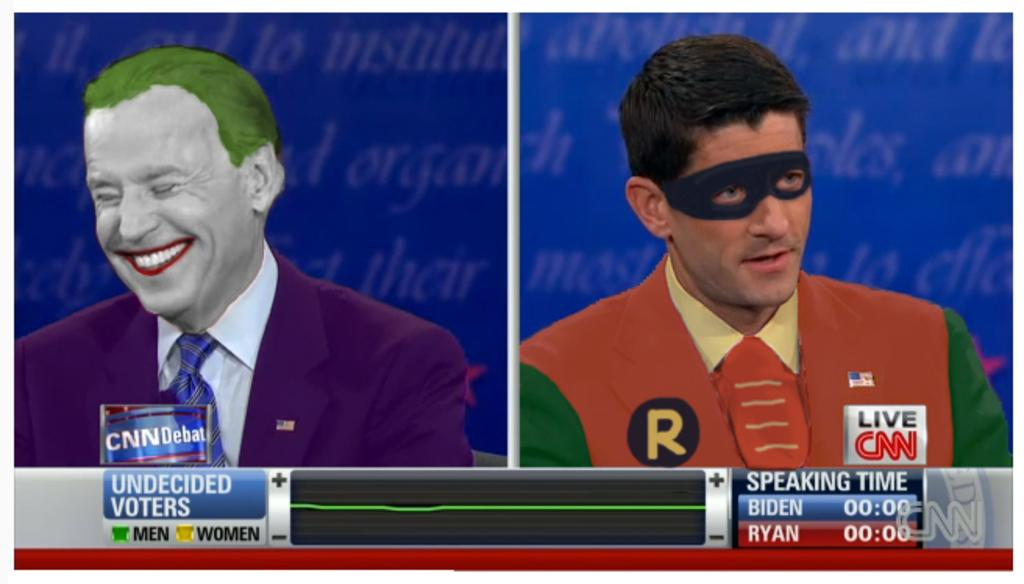How many people are in the image? There are two men in the image. What is the facial expression of the man on the left side? The man on the left side is smiling. What is the man on the right side wearing? The man on the right side is wearing a mask. Are there any sheets hanging from the ceiling in the image? There is no information about sheets hanging from the ceiling in the image. Can you see any cobwebs in the image? There is no information about cobwebs in the image. 